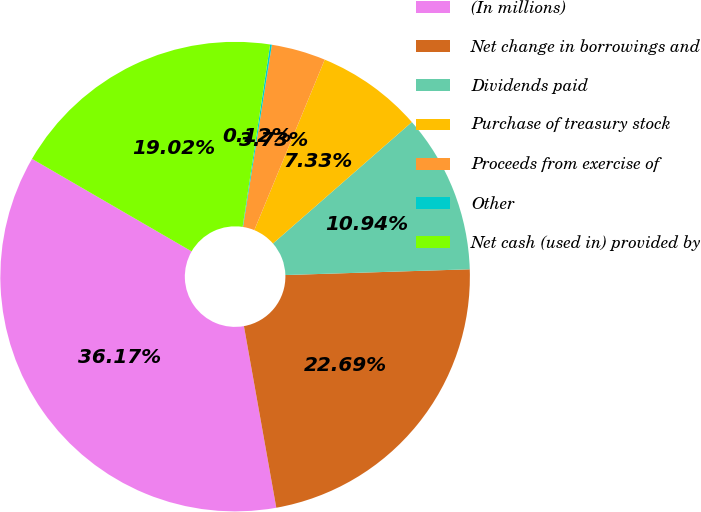<chart> <loc_0><loc_0><loc_500><loc_500><pie_chart><fcel>(In millions)<fcel>Net change in borrowings and<fcel>Dividends paid<fcel>Purchase of treasury stock<fcel>Proceeds from exercise of<fcel>Other<fcel>Net cash (used in) provided by<nl><fcel>36.17%<fcel>22.69%<fcel>10.94%<fcel>7.33%<fcel>3.73%<fcel>0.12%<fcel>19.02%<nl></chart> 